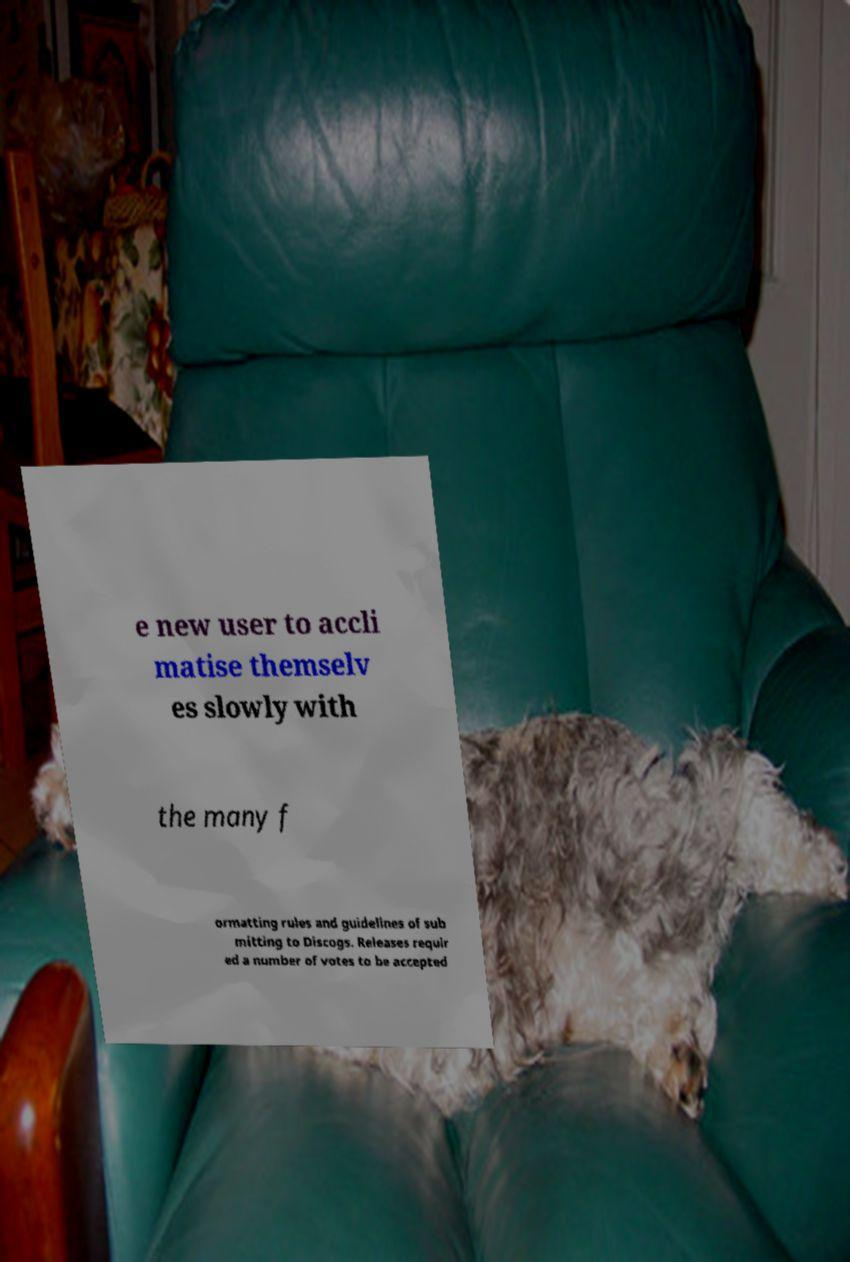Please identify and transcribe the text found in this image. e new user to accli matise themselv es slowly with the many f ormatting rules and guidelines of sub mitting to Discogs. Releases requir ed a number of votes to be accepted 